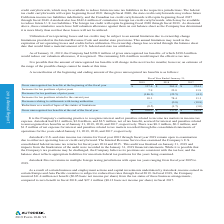According to Autodesk's financial document, What does the pro forma financial information for all periods include? Based on the financial document, the answer is The pro forma financial information for all periods presented includes the business combination accounting effects from the acquisition of PlanGrid including amortization expense from acquired intangible assets, compensation expense, and the interest expense and debt issuance costs related to the term loan agreement. Also, What does the pro forma financial information for fiscal 2019 and 2018 combine? Based on the financial document, the answer is The pro forma financial information for fiscal 2019 and 2018 combines the historical results of the Company, the adjusted historical results of PlanGrid for fiscal 2019 and 2018 considering the date the Company acquired PlanGrid and the effects of the pro forma adjustments described above. Also, What is the total revenue for the fiscal year 2019? Based on the financial document, the answer is $2,632.6. Also, can you calculate: What is the % change in the total revenue from 2018 to 2019? To answer this question, I need to perform calculations using the financial data. The calculation is: (($2,632.6-$2,099.2)/$2,099.2), which equals 25.41 (percentage). The key data points involved are: 2,099.2, 2,632.6. Also, can you calculate: What is the change in the net loss from 2018 to 2019? Based on the calculation: (734.5)-(200.1), the result is -534.4 (in millions). The key data points involved are: 200.1, 734.5. Also, can you calculate: What is the average total revenue from 2018 to 2019? To answer this question, I need to perform calculations using the financial data. The calculation is: (2,632.6+2,099.2)/2 , which equals 2365.9 (in millions). The key data points involved are: 2,099.2, 2,632.6. 